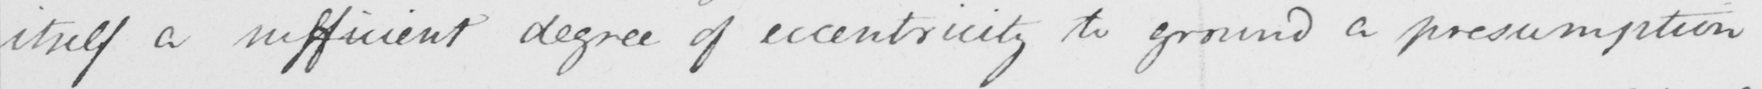Can you read and transcribe this handwriting? itself a sufficient degree of eccentricity to ground a presumption 